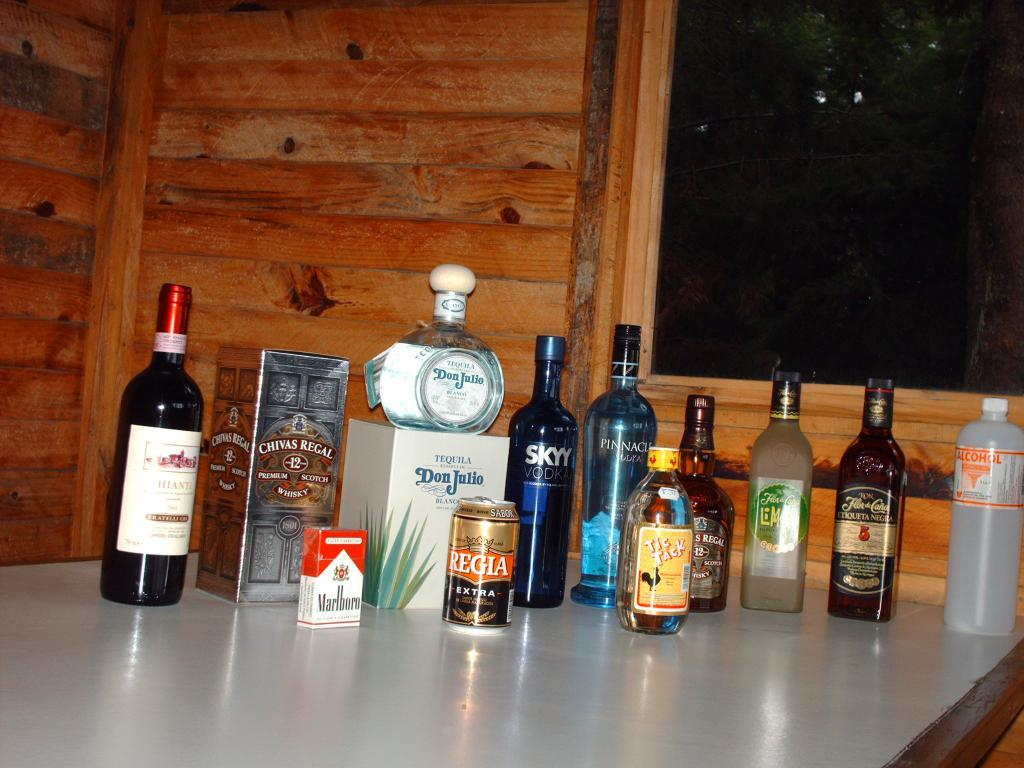<image>
Offer a succinct explanation of the picture presented. A bottle of Don Julio tequila sits in the middle of a table of liquor. 